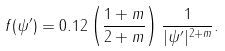<formula> <loc_0><loc_0><loc_500><loc_500>f ( \psi ^ { \prime } ) = 0 . 1 2 \left ( \frac { 1 + m } { 2 + m } \right ) \frac { 1 } { | \psi ^ { \prime } | ^ { 2 + m } } .</formula> 